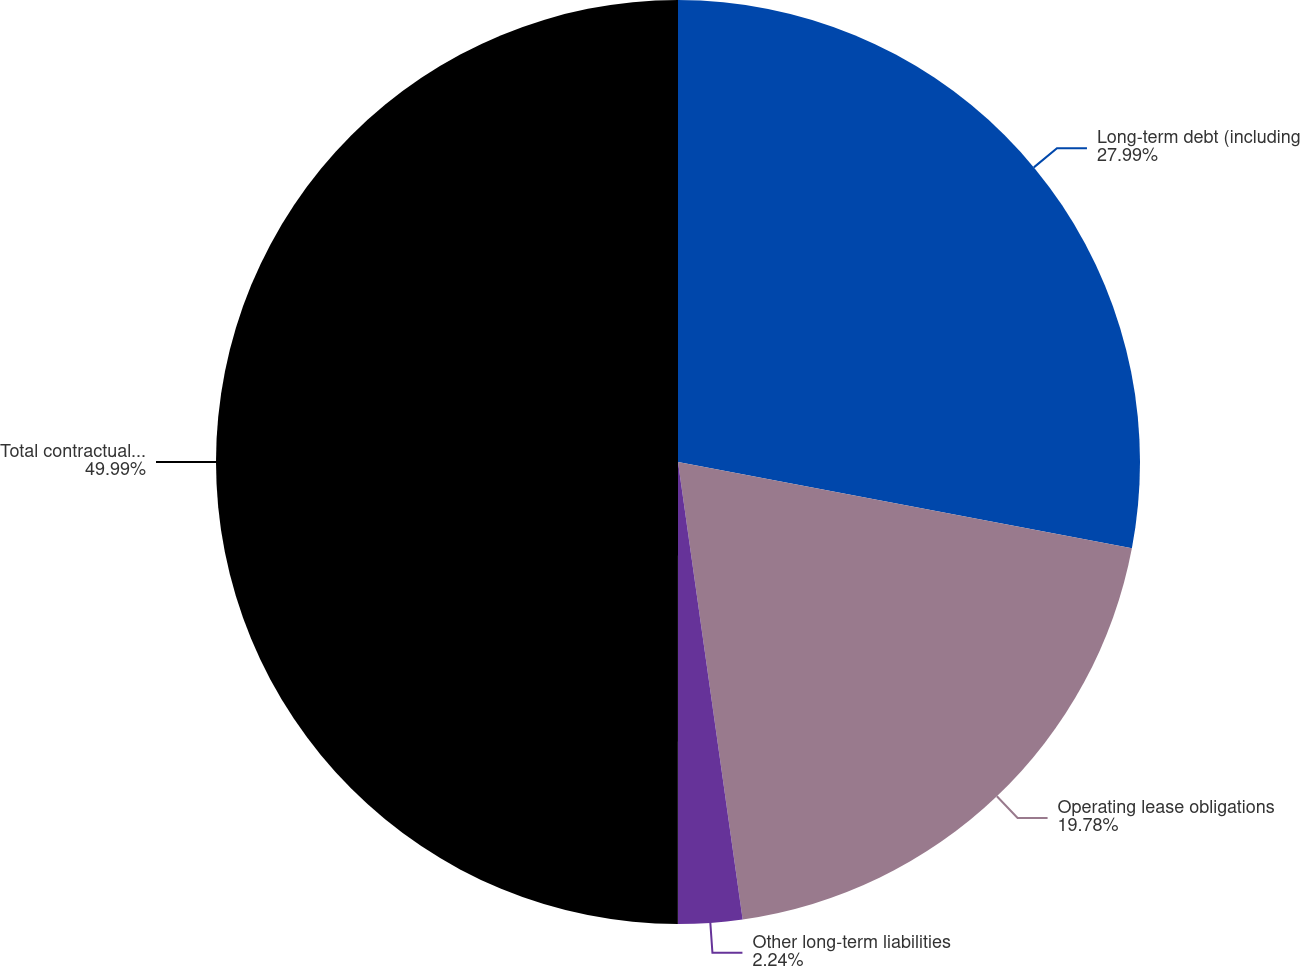<chart> <loc_0><loc_0><loc_500><loc_500><pie_chart><fcel>Long-term debt (including<fcel>Operating lease obligations<fcel>Other long-term liabilities<fcel>Total contractual obligations<nl><fcel>27.99%<fcel>19.78%<fcel>2.24%<fcel>50.0%<nl></chart> 